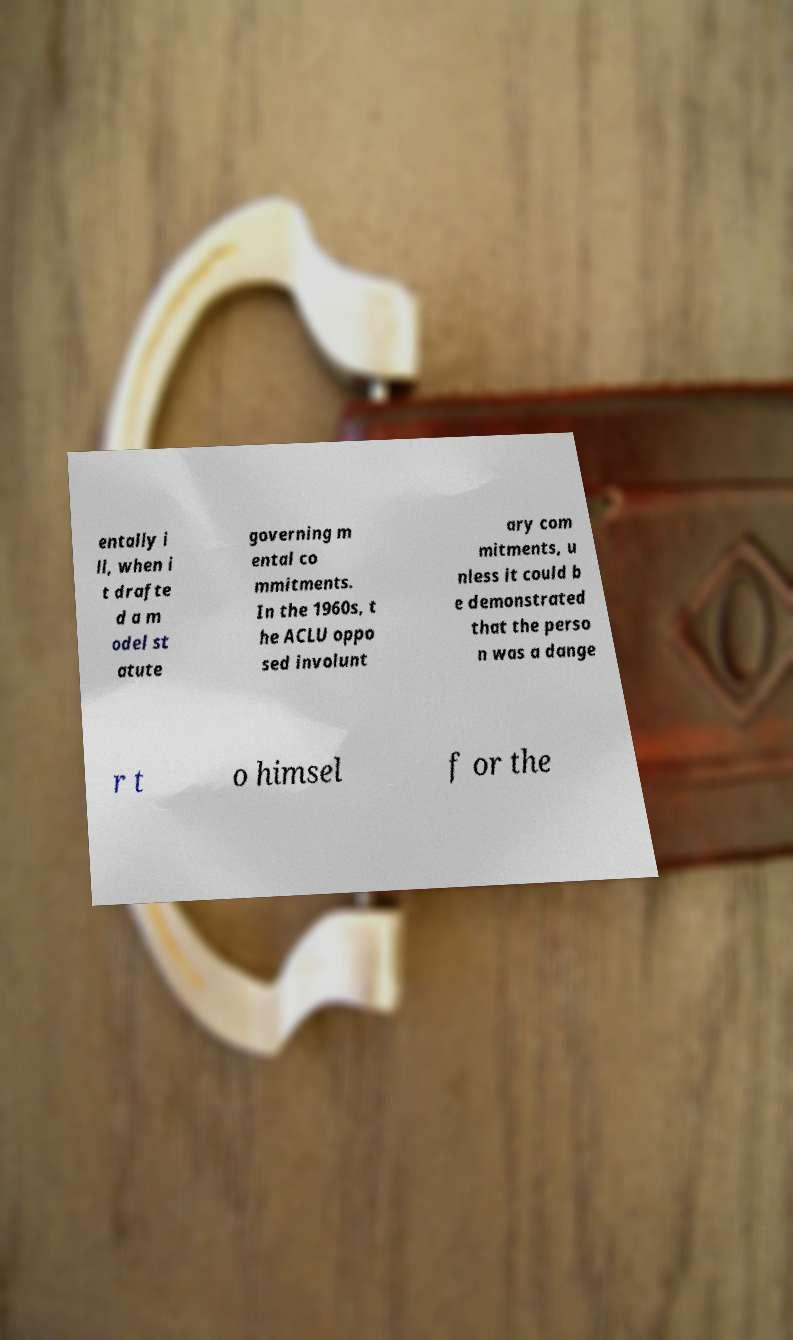Can you read and provide the text displayed in the image?This photo seems to have some interesting text. Can you extract and type it out for me? entally i ll, when i t drafte d a m odel st atute governing m ental co mmitments. In the 1960s, t he ACLU oppo sed involunt ary com mitments, u nless it could b e demonstrated that the perso n was a dange r t o himsel f or the 